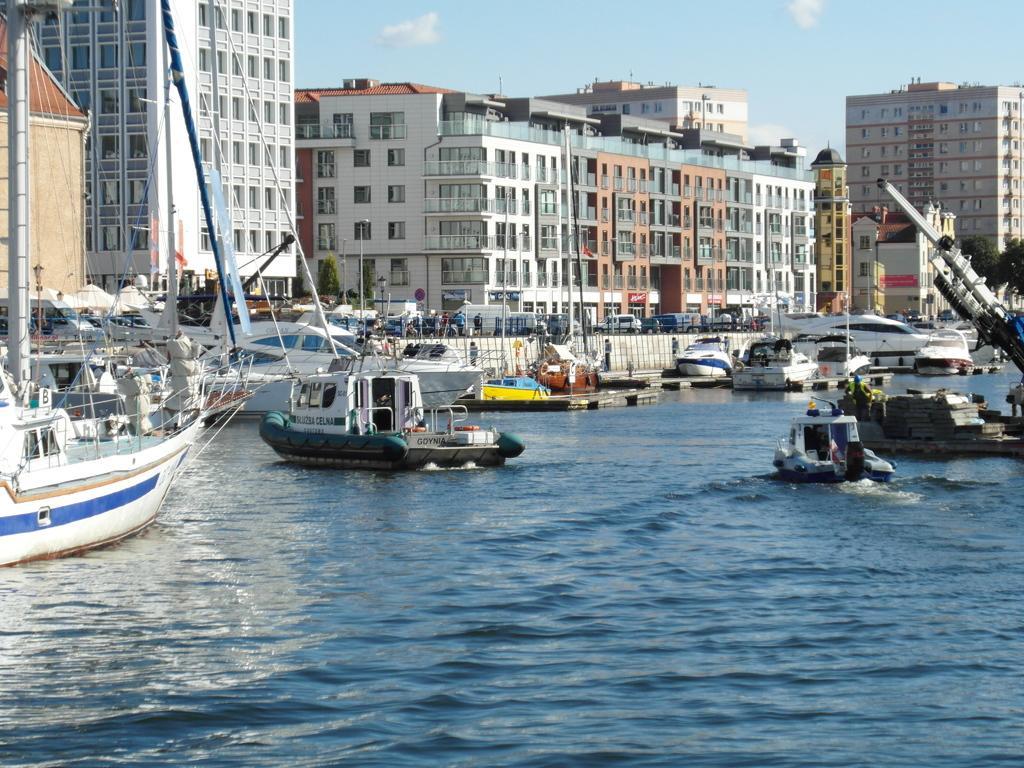Can you describe this image briefly? There are boats on the water. Here we can see buildings, poles, and trees. In the background there is sky. 